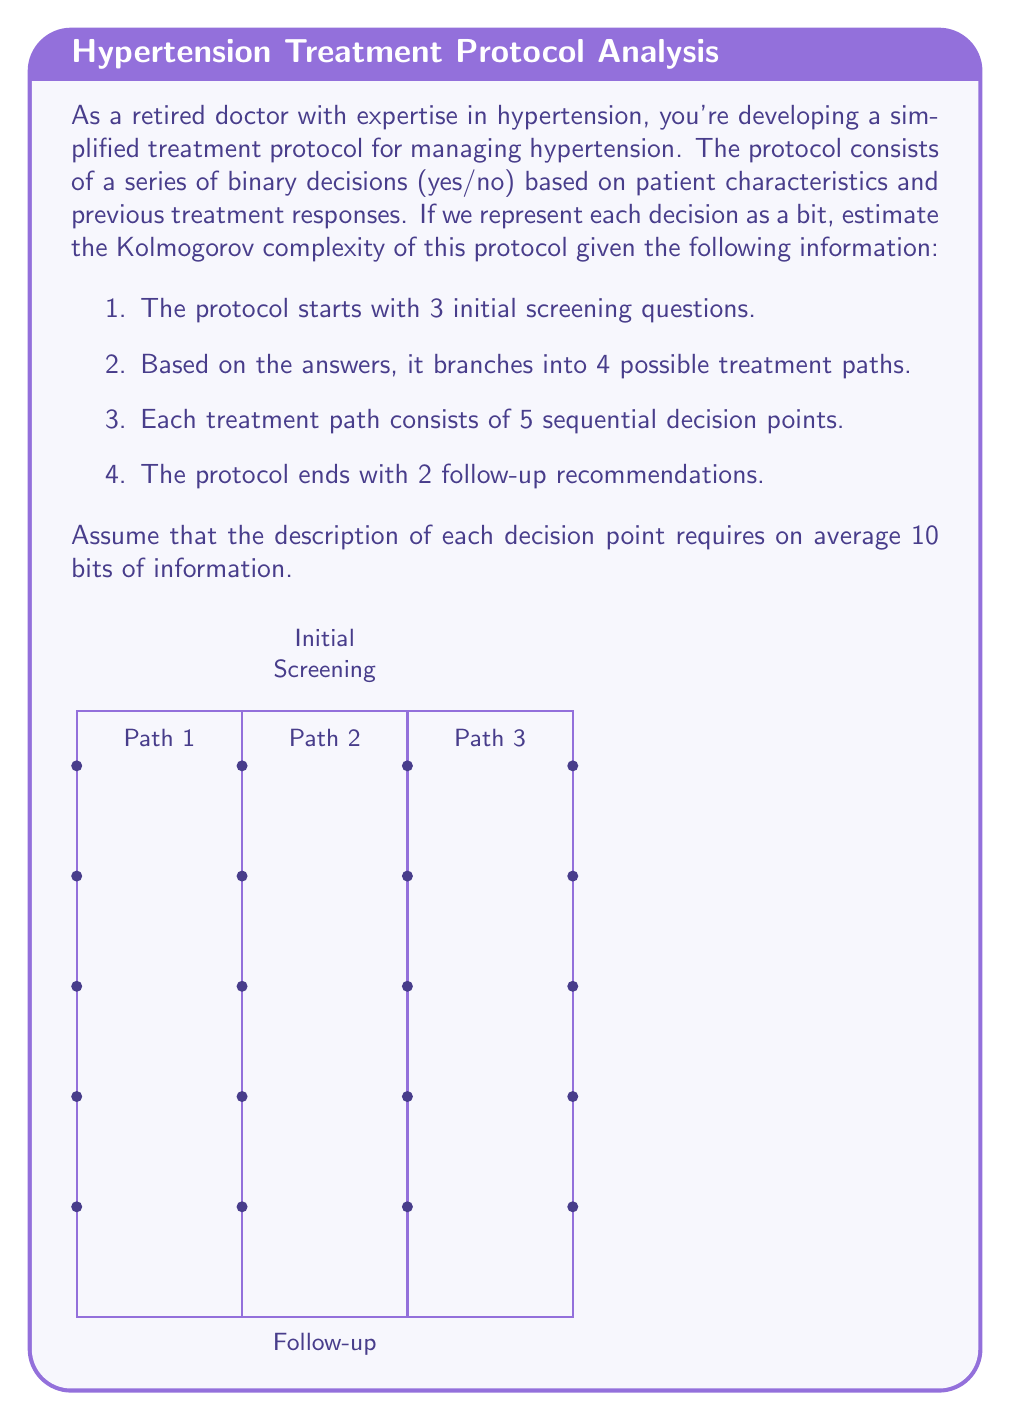Help me with this question. To estimate the Kolmogorov complexity of the hypertension treatment protocol, we need to calculate the minimum number of bits required to describe the entire protocol. Let's break it down step by step:

1. Initial screening questions:
   $3 \text{ questions} \times 10 \text{ bits/question} = 30 \text{ bits}$

2. Branching logic:
   To describe the branching into 4 paths, we need $\log_2(4) = 2 \text{ bits}$

3. Treatment paths:
   $4 \text{ paths} \times 5 \text{ decision points/path} \times 10 \text{ bits/decision} = 200 \text{ bits}$

4. Follow-up recommendations:
   $2 \text{ recommendations} \times 10 \text{ bits/recommendation} = 20 \text{ bits}$

5. Structure description:
   We need some additional bits to describe the overall structure of the protocol. Let's estimate this as:
   $\text{Initial structure} + \text{Branching} + \text{Path structure} + \text{Follow-up structure}$
   $= 10 + 5 + 20 + 5 = 40 \text{ bits}$

Now, let's sum up all the components:

$$\text{Total bits} = 30 + 2 + 200 + 20 + 40 = 292 \text{ bits}$$

Therefore, an estimate of the Kolmogorov complexity of this hypertension treatment protocol is 292 bits.

Note: This is an approximation, as the actual Kolmogorov complexity might be slightly lower if there are patterns or redundancies in the protocol that allow for more efficient encoding.
Answer: $292 \text{ bits}$ 